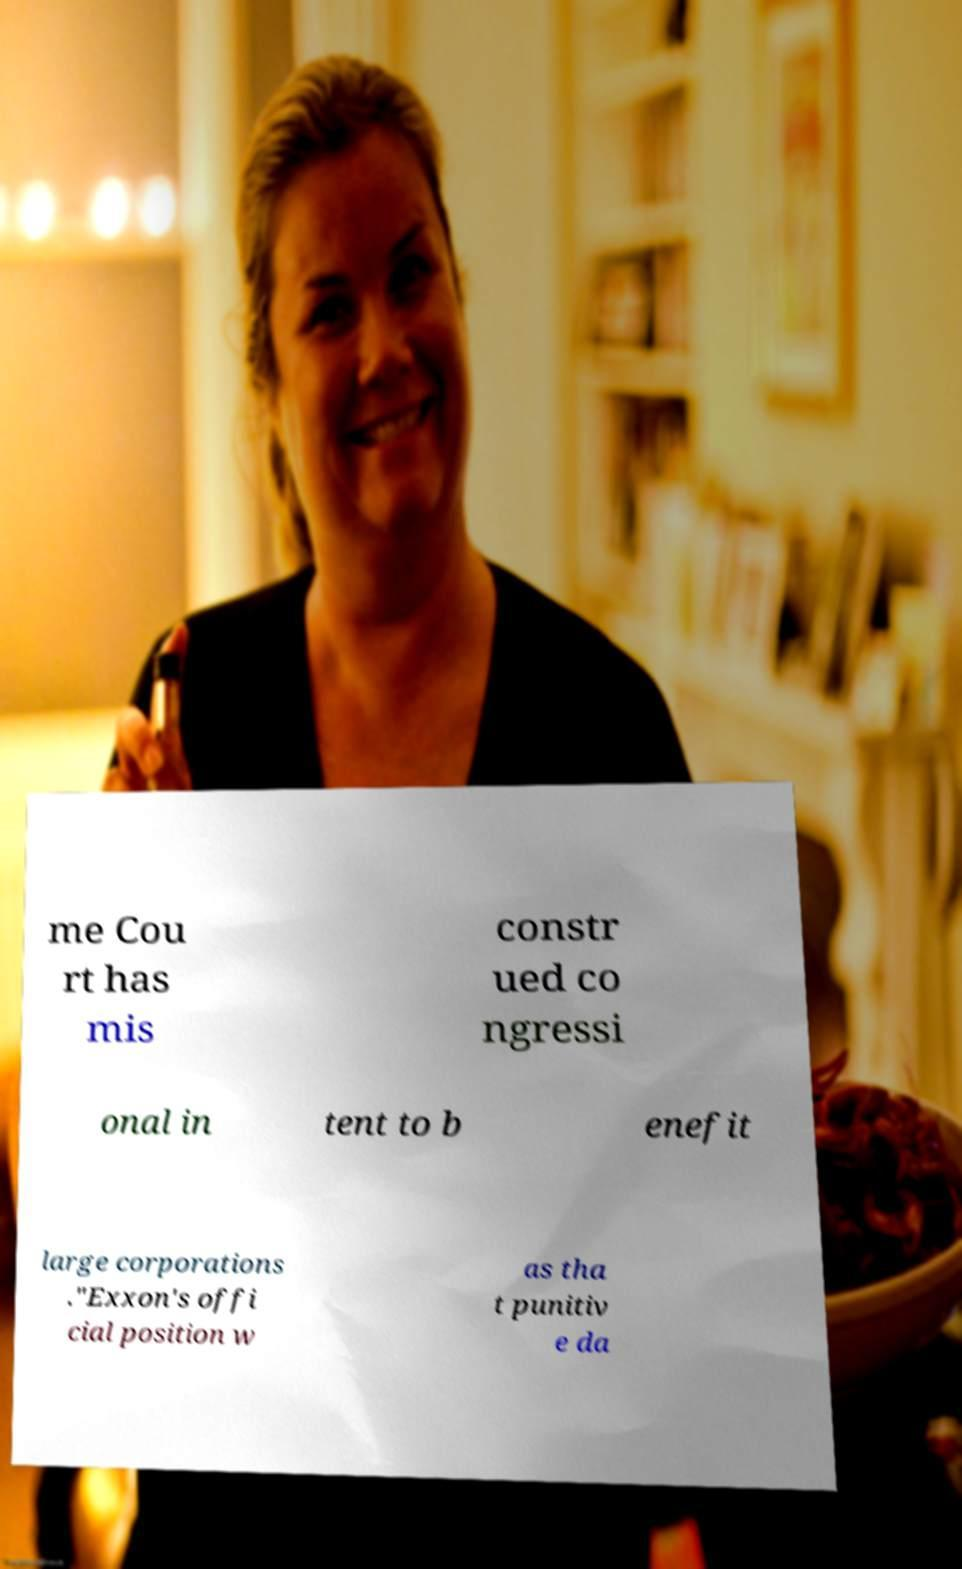There's text embedded in this image that I need extracted. Can you transcribe it verbatim? me Cou rt has mis constr ued co ngressi onal in tent to b enefit large corporations ."Exxon's offi cial position w as tha t punitiv e da 